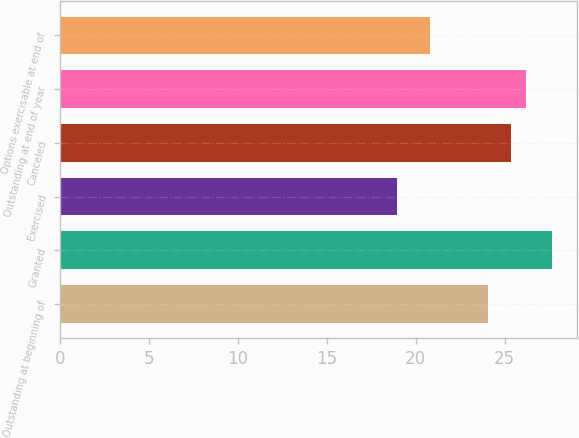<chart> <loc_0><loc_0><loc_500><loc_500><bar_chart><fcel>Outstanding at beginning of<fcel>Granted<fcel>Exercised<fcel>Canceled<fcel>Outstanding at end of year<fcel>Options exercisable at end of<nl><fcel>24.05<fcel>27.66<fcel>18.92<fcel>25.34<fcel>26.21<fcel>20.81<nl></chart> 